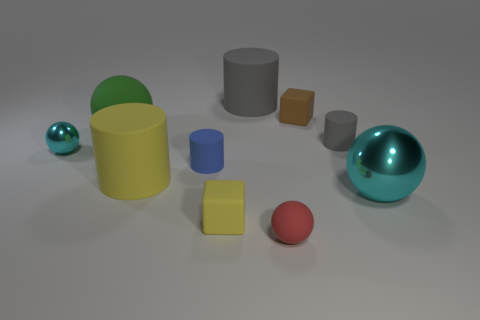Subtract all tiny red rubber spheres. How many spheres are left? 3 Subtract all blue spheres. How many gray cylinders are left? 2 Subtract all red spheres. How many spheres are left? 3 Subtract 1 spheres. How many spheres are left? 3 Subtract all cylinders. How many objects are left? 6 Subtract 0 purple balls. How many objects are left? 10 Subtract all purple balls. Subtract all purple cylinders. How many balls are left? 4 Subtract all tiny gray cylinders. Subtract all large cylinders. How many objects are left? 7 Add 3 small yellow cubes. How many small yellow cubes are left? 4 Add 6 cyan metallic objects. How many cyan metallic objects exist? 8 